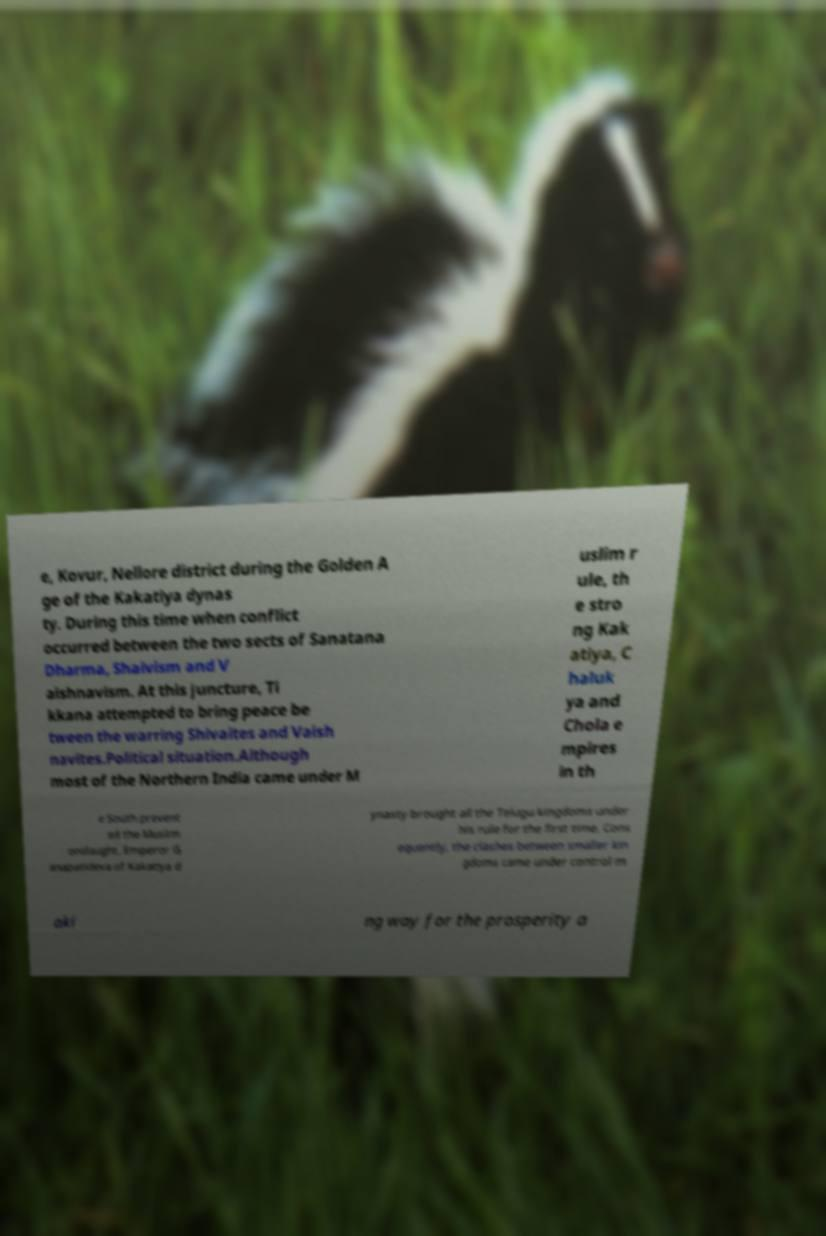For documentation purposes, I need the text within this image transcribed. Could you provide that? e, Kovur, Nellore district during the Golden A ge of the Kakatiya dynas ty. During this time when conflict occurred between the two sects of Sanatana Dharma, Shaivism and V aishnavism. At this juncture, Ti kkana attempted to bring peace be tween the warring Shivaites and Vaish navites.Political situation.Although most of the Northern India came under M uslim r ule, th e stro ng Kak atiya, C haluk ya and Chola e mpires in th e South prevent ed the Muslim onslaught. Emperor G anapatideva of Kakatiya d ynasty brought all the Telugu kingdoms under his rule for the first time. Cons equently, the clashes between smaller kin gdoms came under control m aki ng way for the prosperity a 